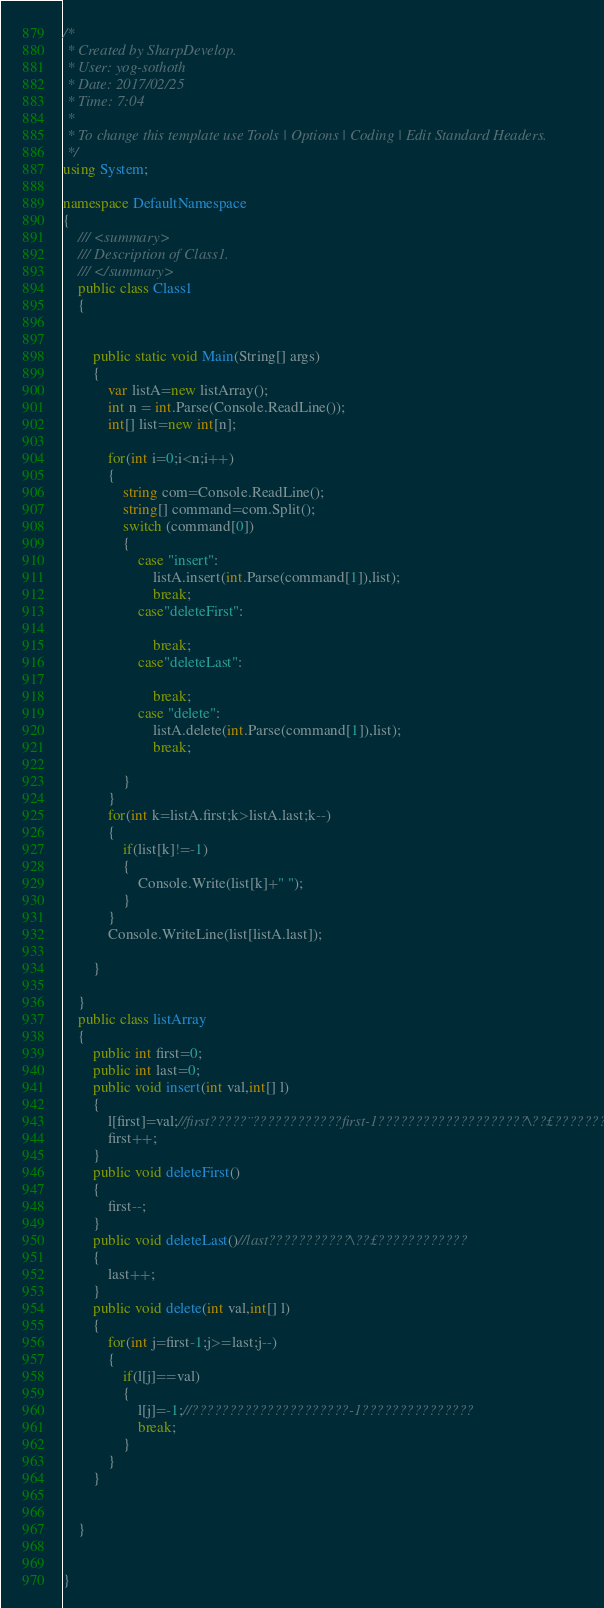Convert code to text. <code><loc_0><loc_0><loc_500><loc_500><_C#_>/*
 * Created by SharpDevelop.
 * User: yog-sothoth
 * Date: 2017/02/25
 * Time: 7:04
 * 
 * To change this template use Tools | Options | Coding | Edit Standard Headers.
 */
using System;

namespace DefaultNamespace
{
	/// <summary>
	/// Description of Class1.
	/// </summary>
	public class Class1
	{
	
		
		public static void Main(String[] args)
		{
			var listA=new listArray();
			int n = int.Parse(Console.ReadLine());
			int[] list=new int[n];
			
			for(int i=0;i<n;i++)
			{
				string com=Console.ReadLine();
				string[] command=com.Split();
				switch (command[0])
				{
					case "insert":
						listA.insert(int.Parse(command[1]),list);
						break;
					case"deleteFirst":
						
						break;
					case"deleteLast":
										
						break;
					case "delete":
						listA.delete(int.Parse(command[1]),list);
						break;
				
				}
			}
			for(int k=listA.first;k>listA.last;k--)
			{
				if(list[k]!=-1)
				{
					Console.Write(list[k]+" ");
				}
			}
			Console.WriteLine(list[listA.last]);
			
		}	
		
	}
	public class listArray
	{
		public int first=0;
		public int last=0;
		public void insert(int val,int[] l)
		{
			l[first]=val;//first?????¨????????????first-1????????????????????\??£?????????
			first++;
		}
		public void deleteFirst()
		{
			first--;
		}
		public void deleteLast()//last???????????\??£????????????
		{
			last++;
		}
		public void delete(int val,int[] l)
		{
			for(int j=first-1;j>=last;j--)
			{
				if(l[j]==val)
				{
					l[j]=-1;//?????????????????????-1???????????????
					break;
				}
			}
		}
		
	
	}
	
	
}</code> 